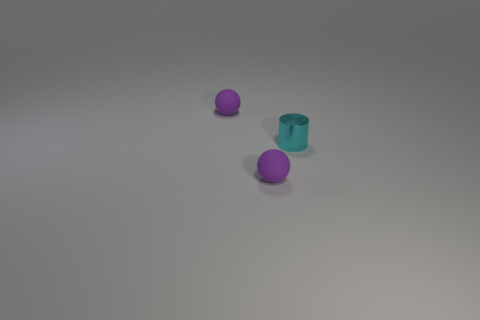What materials do the objects in the image appear to be made from? The cylinders and the sphere appear to be made from a material with a plastic-like texture. The matte surface of the purple objects suggests a non-reflective plastic, while the teal cylinder has a slightly translucent appearance indicative of a frosted glass or semi-opaque plastic. 